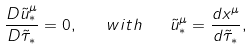Convert formula to latex. <formula><loc_0><loc_0><loc_500><loc_500>\frac { D \tilde { u } _ { * } ^ { \mu } } { D \tilde { \tau } _ { * } } = 0 , \quad w i t h \quad \tilde { u } _ { * } ^ { \mu } = \frac { d x ^ { \mu } } { d \tilde { \tau } _ { * } } ,</formula> 